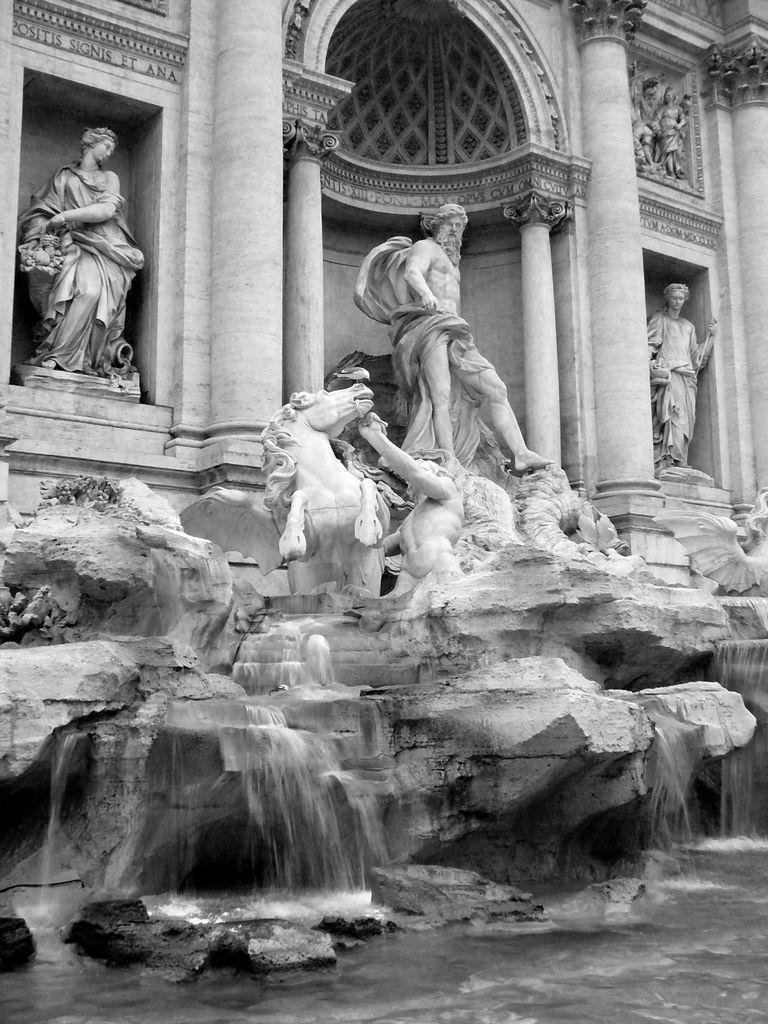Describe this image in one or two sentences. In this picture we can observe statues of human beings and a horse. We can observe some water. This is a black and white image. There are some pillars. 